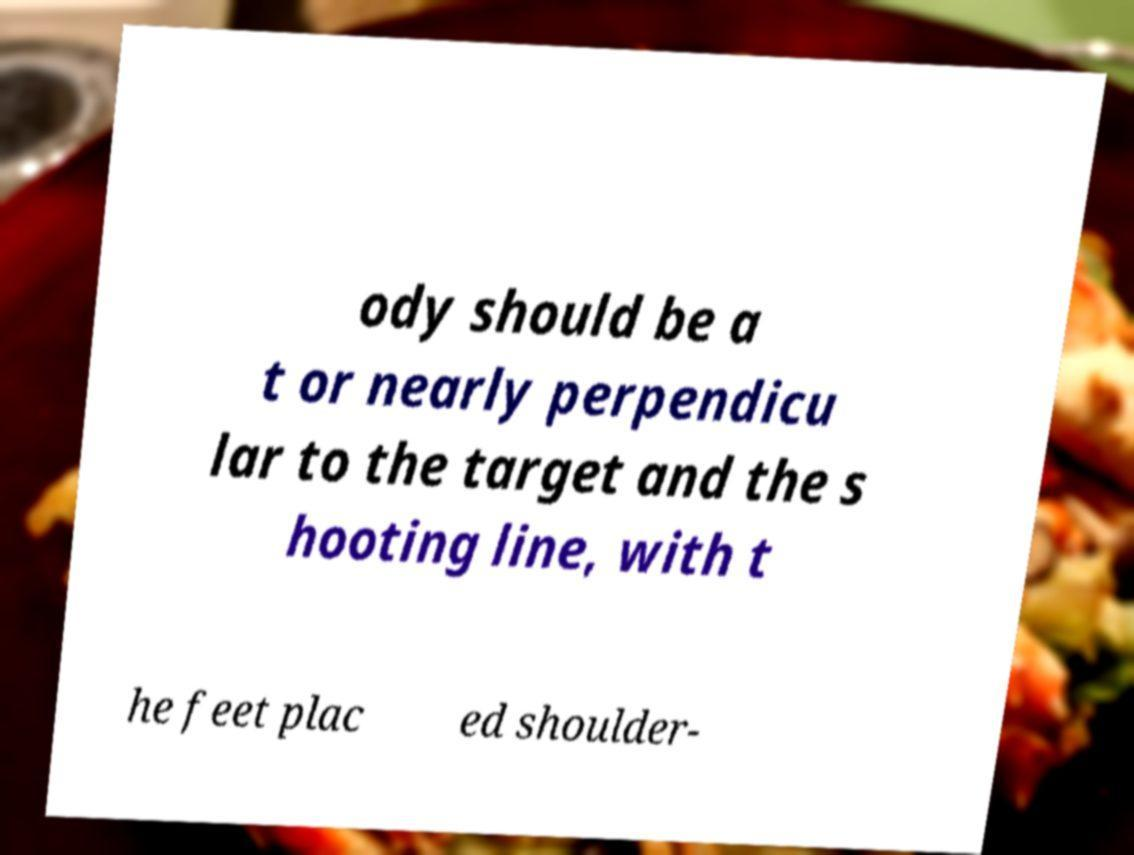Could you extract and type out the text from this image? ody should be a t or nearly perpendicu lar to the target and the s hooting line, with t he feet plac ed shoulder- 